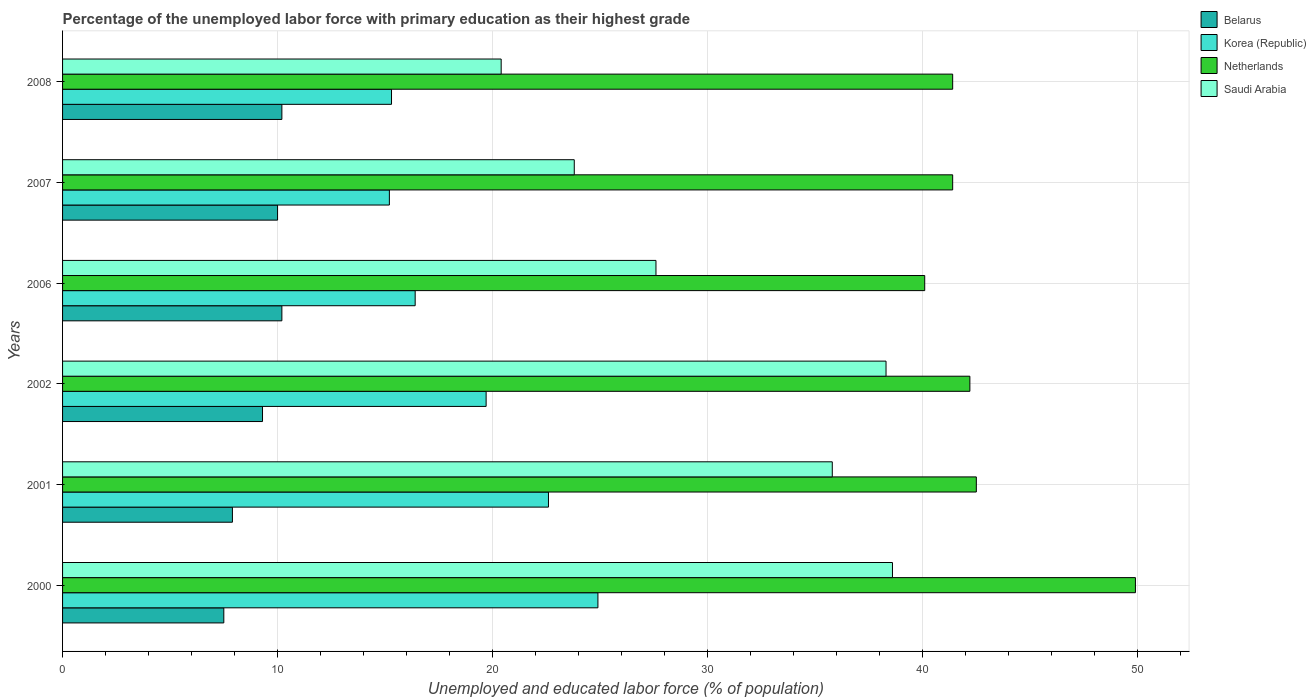How many groups of bars are there?
Keep it short and to the point. 6. How many bars are there on the 1st tick from the top?
Provide a succinct answer. 4. How many bars are there on the 3rd tick from the bottom?
Provide a short and direct response. 4. What is the label of the 3rd group of bars from the top?
Offer a very short reply. 2006. What is the percentage of the unemployed labor force with primary education in Netherlands in 2007?
Provide a short and direct response. 41.4. Across all years, what is the maximum percentage of the unemployed labor force with primary education in Saudi Arabia?
Keep it short and to the point. 38.6. What is the total percentage of the unemployed labor force with primary education in Netherlands in the graph?
Provide a short and direct response. 257.5. What is the difference between the percentage of the unemployed labor force with primary education in Korea (Republic) in 2006 and that in 2007?
Offer a terse response. 1.2. What is the difference between the percentage of the unemployed labor force with primary education in Korea (Republic) in 2007 and the percentage of the unemployed labor force with primary education in Saudi Arabia in 2001?
Your response must be concise. -20.6. What is the average percentage of the unemployed labor force with primary education in Belarus per year?
Your answer should be very brief. 9.18. In the year 2006, what is the difference between the percentage of the unemployed labor force with primary education in Netherlands and percentage of the unemployed labor force with primary education in Saudi Arabia?
Provide a succinct answer. 12.5. In how many years, is the percentage of the unemployed labor force with primary education in Belarus greater than 10 %?
Offer a terse response. 2. What is the ratio of the percentage of the unemployed labor force with primary education in Netherlands in 2000 to that in 2007?
Provide a succinct answer. 1.21. Is the percentage of the unemployed labor force with primary education in Netherlands in 2006 less than that in 2008?
Offer a very short reply. Yes. Is the difference between the percentage of the unemployed labor force with primary education in Netherlands in 2001 and 2006 greater than the difference between the percentage of the unemployed labor force with primary education in Saudi Arabia in 2001 and 2006?
Give a very brief answer. No. What is the difference between the highest and the second highest percentage of the unemployed labor force with primary education in Saudi Arabia?
Provide a succinct answer. 0.3. What is the difference between the highest and the lowest percentage of the unemployed labor force with primary education in Saudi Arabia?
Give a very brief answer. 18.2. In how many years, is the percentage of the unemployed labor force with primary education in Belarus greater than the average percentage of the unemployed labor force with primary education in Belarus taken over all years?
Your answer should be very brief. 4. Is the sum of the percentage of the unemployed labor force with primary education in Netherlands in 2002 and 2008 greater than the maximum percentage of the unemployed labor force with primary education in Korea (Republic) across all years?
Ensure brevity in your answer.  Yes. Is it the case that in every year, the sum of the percentage of the unemployed labor force with primary education in Belarus and percentage of the unemployed labor force with primary education in Netherlands is greater than the sum of percentage of the unemployed labor force with primary education in Saudi Arabia and percentage of the unemployed labor force with primary education in Korea (Republic)?
Offer a terse response. No. What does the 3rd bar from the bottom in 2000 represents?
Provide a succinct answer. Netherlands. Is it the case that in every year, the sum of the percentage of the unemployed labor force with primary education in Saudi Arabia and percentage of the unemployed labor force with primary education in Netherlands is greater than the percentage of the unemployed labor force with primary education in Belarus?
Make the answer very short. Yes. Does the graph contain grids?
Keep it short and to the point. Yes. How many legend labels are there?
Keep it short and to the point. 4. How are the legend labels stacked?
Provide a succinct answer. Vertical. What is the title of the graph?
Offer a very short reply. Percentage of the unemployed labor force with primary education as their highest grade. Does "Cambodia" appear as one of the legend labels in the graph?
Your answer should be compact. No. What is the label or title of the X-axis?
Your response must be concise. Unemployed and educated labor force (% of population). What is the Unemployed and educated labor force (% of population) of Korea (Republic) in 2000?
Your response must be concise. 24.9. What is the Unemployed and educated labor force (% of population) in Netherlands in 2000?
Your answer should be compact. 49.9. What is the Unemployed and educated labor force (% of population) in Saudi Arabia in 2000?
Offer a terse response. 38.6. What is the Unemployed and educated labor force (% of population) in Belarus in 2001?
Keep it short and to the point. 7.9. What is the Unemployed and educated labor force (% of population) in Korea (Republic) in 2001?
Your answer should be very brief. 22.6. What is the Unemployed and educated labor force (% of population) of Netherlands in 2001?
Your answer should be very brief. 42.5. What is the Unemployed and educated labor force (% of population) of Saudi Arabia in 2001?
Provide a short and direct response. 35.8. What is the Unemployed and educated labor force (% of population) of Belarus in 2002?
Make the answer very short. 9.3. What is the Unemployed and educated labor force (% of population) in Korea (Republic) in 2002?
Your answer should be compact. 19.7. What is the Unemployed and educated labor force (% of population) in Netherlands in 2002?
Your response must be concise. 42.2. What is the Unemployed and educated labor force (% of population) in Saudi Arabia in 2002?
Your answer should be compact. 38.3. What is the Unemployed and educated labor force (% of population) of Belarus in 2006?
Provide a succinct answer. 10.2. What is the Unemployed and educated labor force (% of population) of Korea (Republic) in 2006?
Offer a terse response. 16.4. What is the Unemployed and educated labor force (% of population) of Netherlands in 2006?
Your answer should be compact. 40.1. What is the Unemployed and educated labor force (% of population) of Saudi Arabia in 2006?
Your answer should be compact. 27.6. What is the Unemployed and educated labor force (% of population) in Korea (Republic) in 2007?
Your response must be concise. 15.2. What is the Unemployed and educated labor force (% of population) in Netherlands in 2007?
Make the answer very short. 41.4. What is the Unemployed and educated labor force (% of population) of Saudi Arabia in 2007?
Your answer should be compact. 23.8. What is the Unemployed and educated labor force (% of population) of Belarus in 2008?
Ensure brevity in your answer.  10.2. What is the Unemployed and educated labor force (% of population) of Korea (Republic) in 2008?
Offer a very short reply. 15.3. What is the Unemployed and educated labor force (% of population) of Netherlands in 2008?
Provide a succinct answer. 41.4. What is the Unemployed and educated labor force (% of population) of Saudi Arabia in 2008?
Provide a succinct answer. 20.4. Across all years, what is the maximum Unemployed and educated labor force (% of population) in Belarus?
Provide a short and direct response. 10.2. Across all years, what is the maximum Unemployed and educated labor force (% of population) of Korea (Republic)?
Provide a short and direct response. 24.9. Across all years, what is the maximum Unemployed and educated labor force (% of population) of Netherlands?
Your answer should be compact. 49.9. Across all years, what is the maximum Unemployed and educated labor force (% of population) of Saudi Arabia?
Give a very brief answer. 38.6. Across all years, what is the minimum Unemployed and educated labor force (% of population) in Belarus?
Your answer should be compact. 7.5. Across all years, what is the minimum Unemployed and educated labor force (% of population) in Korea (Republic)?
Give a very brief answer. 15.2. Across all years, what is the minimum Unemployed and educated labor force (% of population) of Netherlands?
Offer a very short reply. 40.1. Across all years, what is the minimum Unemployed and educated labor force (% of population) in Saudi Arabia?
Make the answer very short. 20.4. What is the total Unemployed and educated labor force (% of population) of Belarus in the graph?
Your answer should be very brief. 55.1. What is the total Unemployed and educated labor force (% of population) in Korea (Republic) in the graph?
Provide a succinct answer. 114.1. What is the total Unemployed and educated labor force (% of population) of Netherlands in the graph?
Provide a short and direct response. 257.5. What is the total Unemployed and educated labor force (% of population) in Saudi Arabia in the graph?
Offer a very short reply. 184.5. What is the difference between the Unemployed and educated labor force (% of population) of Belarus in 2000 and that in 2001?
Your response must be concise. -0.4. What is the difference between the Unemployed and educated labor force (% of population) in Korea (Republic) in 2000 and that in 2001?
Your answer should be compact. 2.3. What is the difference between the Unemployed and educated labor force (% of population) in Belarus in 2000 and that in 2002?
Your response must be concise. -1.8. What is the difference between the Unemployed and educated labor force (% of population) in Korea (Republic) in 2000 and that in 2002?
Offer a terse response. 5.2. What is the difference between the Unemployed and educated labor force (% of population) in Netherlands in 2000 and that in 2002?
Give a very brief answer. 7.7. What is the difference between the Unemployed and educated labor force (% of population) in Belarus in 2000 and that in 2006?
Give a very brief answer. -2.7. What is the difference between the Unemployed and educated labor force (% of population) in Korea (Republic) in 2000 and that in 2006?
Your answer should be very brief. 8.5. What is the difference between the Unemployed and educated labor force (% of population) in Korea (Republic) in 2000 and that in 2008?
Your answer should be very brief. 9.6. What is the difference between the Unemployed and educated labor force (% of population) in Netherlands in 2000 and that in 2008?
Offer a terse response. 8.5. What is the difference between the Unemployed and educated labor force (% of population) in Saudi Arabia in 2000 and that in 2008?
Provide a short and direct response. 18.2. What is the difference between the Unemployed and educated labor force (% of population) in Belarus in 2001 and that in 2006?
Make the answer very short. -2.3. What is the difference between the Unemployed and educated labor force (% of population) of Netherlands in 2001 and that in 2006?
Your answer should be compact. 2.4. What is the difference between the Unemployed and educated labor force (% of population) of Saudi Arabia in 2001 and that in 2006?
Your response must be concise. 8.2. What is the difference between the Unemployed and educated labor force (% of population) of Netherlands in 2001 and that in 2007?
Offer a terse response. 1.1. What is the difference between the Unemployed and educated labor force (% of population) in Saudi Arabia in 2001 and that in 2007?
Provide a short and direct response. 12. What is the difference between the Unemployed and educated labor force (% of population) in Saudi Arabia in 2001 and that in 2008?
Give a very brief answer. 15.4. What is the difference between the Unemployed and educated labor force (% of population) of Belarus in 2002 and that in 2007?
Ensure brevity in your answer.  -0.7. What is the difference between the Unemployed and educated labor force (% of population) in Korea (Republic) in 2002 and that in 2007?
Provide a succinct answer. 4.5. What is the difference between the Unemployed and educated labor force (% of population) in Netherlands in 2002 and that in 2007?
Provide a short and direct response. 0.8. What is the difference between the Unemployed and educated labor force (% of population) in Netherlands in 2002 and that in 2008?
Offer a very short reply. 0.8. What is the difference between the Unemployed and educated labor force (% of population) in Korea (Republic) in 2006 and that in 2007?
Your answer should be compact. 1.2. What is the difference between the Unemployed and educated labor force (% of population) of Saudi Arabia in 2006 and that in 2007?
Offer a terse response. 3.8. What is the difference between the Unemployed and educated labor force (% of population) of Saudi Arabia in 2006 and that in 2008?
Give a very brief answer. 7.2. What is the difference between the Unemployed and educated labor force (% of population) in Saudi Arabia in 2007 and that in 2008?
Make the answer very short. 3.4. What is the difference between the Unemployed and educated labor force (% of population) in Belarus in 2000 and the Unemployed and educated labor force (% of population) in Korea (Republic) in 2001?
Provide a succinct answer. -15.1. What is the difference between the Unemployed and educated labor force (% of population) in Belarus in 2000 and the Unemployed and educated labor force (% of population) in Netherlands in 2001?
Make the answer very short. -35. What is the difference between the Unemployed and educated labor force (% of population) of Belarus in 2000 and the Unemployed and educated labor force (% of population) of Saudi Arabia in 2001?
Ensure brevity in your answer.  -28.3. What is the difference between the Unemployed and educated labor force (% of population) of Korea (Republic) in 2000 and the Unemployed and educated labor force (% of population) of Netherlands in 2001?
Make the answer very short. -17.6. What is the difference between the Unemployed and educated labor force (% of population) in Korea (Republic) in 2000 and the Unemployed and educated labor force (% of population) in Saudi Arabia in 2001?
Give a very brief answer. -10.9. What is the difference between the Unemployed and educated labor force (% of population) of Netherlands in 2000 and the Unemployed and educated labor force (% of population) of Saudi Arabia in 2001?
Offer a very short reply. 14.1. What is the difference between the Unemployed and educated labor force (% of population) of Belarus in 2000 and the Unemployed and educated labor force (% of population) of Korea (Republic) in 2002?
Your answer should be very brief. -12.2. What is the difference between the Unemployed and educated labor force (% of population) in Belarus in 2000 and the Unemployed and educated labor force (% of population) in Netherlands in 2002?
Provide a short and direct response. -34.7. What is the difference between the Unemployed and educated labor force (% of population) of Belarus in 2000 and the Unemployed and educated labor force (% of population) of Saudi Arabia in 2002?
Provide a short and direct response. -30.8. What is the difference between the Unemployed and educated labor force (% of population) of Korea (Republic) in 2000 and the Unemployed and educated labor force (% of population) of Netherlands in 2002?
Your answer should be compact. -17.3. What is the difference between the Unemployed and educated labor force (% of population) in Korea (Republic) in 2000 and the Unemployed and educated labor force (% of population) in Saudi Arabia in 2002?
Ensure brevity in your answer.  -13.4. What is the difference between the Unemployed and educated labor force (% of population) of Belarus in 2000 and the Unemployed and educated labor force (% of population) of Netherlands in 2006?
Offer a terse response. -32.6. What is the difference between the Unemployed and educated labor force (% of population) in Belarus in 2000 and the Unemployed and educated labor force (% of population) in Saudi Arabia in 2006?
Your answer should be very brief. -20.1. What is the difference between the Unemployed and educated labor force (% of population) of Korea (Republic) in 2000 and the Unemployed and educated labor force (% of population) of Netherlands in 2006?
Your response must be concise. -15.2. What is the difference between the Unemployed and educated labor force (% of population) of Korea (Republic) in 2000 and the Unemployed and educated labor force (% of population) of Saudi Arabia in 2006?
Provide a short and direct response. -2.7. What is the difference between the Unemployed and educated labor force (% of population) of Netherlands in 2000 and the Unemployed and educated labor force (% of population) of Saudi Arabia in 2006?
Offer a terse response. 22.3. What is the difference between the Unemployed and educated labor force (% of population) in Belarus in 2000 and the Unemployed and educated labor force (% of population) in Netherlands in 2007?
Keep it short and to the point. -33.9. What is the difference between the Unemployed and educated labor force (% of population) in Belarus in 2000 and the Unemployed and educated labor force (% of population) in Saudi Arabia in 2007?
Give a very brief answer. -16.3. What is the difference between the Unemployed and educated labor force (% of population) of Korea (Republic) in 2000 and the Unemployed and educated labor force (% of population) of Netherlands in 2007?
Your answer should be compact. -16.5. What is the difference between the Unemployed and educated labor force (% of population) of Korea (Republic) in 2000 and the Unemployed and educated labor force (% of population) of Saudi Arabia in 2007?
Keep it short and to the point. 1.1. What is the difference between the Unemployed and educated labor force (% of population) of Netherlands in 2000 and the Unemployed and educated labor force (% of population) of Saudi Arabia in 2007?
Offer a very short reply. 26.1. What is the difference between the Unemployed and educated labor force (% of population) of Belarus in 2000 and the Unemployed and educated labor force (% of population) of Netherlands in 2008?
Provide a short and direct response. -33.9. What is the difference between the Unemployed and educated labor force (% of population) of Korea (Republic) in 2000 and the Unemployed and educated labor force (% of population) of Netherlands in 2008?
Ensure brevity in your answer.  -16.5. What is the difference between the Unemployed and educated labor force (% of population) of Netherlands in 2000 and the Unemployed and educated labor force (% of population) of Saudi Arabia in 2008?
Your answer should be very brief. 29.5. What is the difference between the Unemployed and educated labor force (% of population) of Belarus in 2001 and the Unemployed and educated labor force (% of population) of Netherlands in 2002?
Keep it short and to the point. -34.3. What is the difference between the Unemployed and educated labor force (% of population) in Belarus in 2001 and the Unemployed and educated labor force (% of population) in Saudi Arabia in 2002?
Your response must be concise. -30.4. What is the difference between the Unemployed and educated labor force (% of population) of Korea (Republic) in 2001 and the Unemployed and educated labor force (% of population) of Netherlands in 2002?
Offer a terse response. -19.6. What is the difference between the Unemployed and educated labor force (% of population) of Korea (Republic) in 2001 and the Unemployed and educated labor force (% of population) of Saudi Arabia in 2002?
Provide a succinct answer. -15.7. What is the difference between the Unemployed and educated labor force (% of population) of Netherlands in 2001 and the Unemployed and educated labor force (% of population) of Saudi Arabia in 2002?
Keep it short and to the point. 4.2. What is the difference between the Unemployed and educated labor force (% of population) in Belarus in 2001 and the Unemployed and educated labor force (% of population) in Korea (Republic) in 2006?
Your response must be concise. -8.5. What is the difference between the Unemployed and educated labor force (% of population) of Belarus in 2001 and the Unemployed and educated labor force (% of population) of Netherlands in 2006?
Your response must be concise. -32.2. What is the difference between the Unemployed and educated labor force (% of population) of Belarus in 2001 and the Unemployed and educated labor force (% of population) of Saudi Arabia in 2006?
Offer a very short reply. -19.7. What is the difference between the Unemployed and educated labor force (% of population) of Korea (Republic) in 2001 and the Unemployed and educated labor force (% of population) of Netherlands in 2006?
Your answer should be very brief. -17.5. What is the difference between the Unemployed and educated labor force (% of population) of Korea (Republic) in 2001 and the Unemployed and educated labor force (% of population) of Saudi Arabia in 2006?
Keep it short and to the point. -5. What is the difference between the Unemployed and educated labor force (% of population) in Belarus in 2001 and the Unemployed and educated labor force (% of population) in Netherlands in 2007?
Offer a very short reply. -33.5. What is the difference between the Unemployed and educated labor force (% of population) in Belarus in 2001 and the Unemployed and educated labor force (% of population) in Saudi Arabia in 2007?
Offer a terse response. -15.9. What is the difference between the Unemployed and educated labor force (% of population) in Korea (Republic) in 2001 and the Unemployed and educated labor force (% of population) in Netherlands in 2007?
Keep it short and to the point. -18.8. What is the difference between the Unemployed and educated labor force (% of population) in Korea (Republic) in 2001 and the Unemployed and educated labor force (% of population) in Saudi Arabia in 2007?
Your answer should be very brief. -1.2. What is the difference between the Unemployed and educated labor force (% of population) in Netherlands in 2001 and the Unemployed and educated labor force (% of population) in Saudi Arabia in 2007?
Give a very brief answer. 18.7. What is the difference between the Unemployed and educated labor force (% of population) in Belarus in 2001 and the Unemployed and educated labor force (% of population) in Netherlands in 2008?
Your answer should be very brief. -33.5. What is the difference between the Unemployed and educated labor force (% of population) of Korea (Republic) in 2001 and the Unemployed and educated labor force (% of population) of Netherlands in 2008?
Your answer should be very brief. -18.8. What is the difference between the Unemployed and educated labor force (% of population) in Korea (Republic) in 2001 and the Unemployed and educated labor force (% of population) in Saudi Arabia in 2008?
Offer a very short reply. 2.2. What is the difference between the Unemployed and educated labor force (% of population) of Netherlands in 2001 and the Unemployed and educated labor force (% of population) of Saudi Arabia in 2008?
Offer a very short reply. 22.1. What is the difference between the Unemployed and educated labor force (% of population) of Belarus in 2002 and the Unemployed and educated labor force (% of population) of Korea (Republic) in 2006?
Provide a succinct answer. -7.1. What is the difference between the Unemployed and educated labor force (% of population) of Belarus in 2002 and the Unemployed and educated labor force (% of population) of Netherlands in 2006?
Ensure brevity in your answer.  -30.8. What is the difference between the Unemployed and educated labor force (% of population) of Belarus in 2002 and the Unemployed and educated labor force (% of population) of Saudi Arabia in 2006?
Keep it short and to the point. -18.3. What is the difference between the Unemployed and educated labor force (% of population) of Korea (Republic) in 2002 and the Unemployed and educated labor force (% of population) of Netherlands in 2006?
Offer a very short reply. -20.4. What is the difference between the Unemployed and educated labor force (% of population) of Netherlands in 2002 and the Unemployed and educated labor force (% of population) of Saudi Arabia in 2006?
Offer a very short reply. 14.6. What is the difference between the Unemployed and educated labor force (% of population) of Belarus in 2002 and the Unemployed and educated labor force (% of population) of Netherlands in 2007?
Offer a terse response. -32.1. What is the difference between the Unemployed and educated labor force (% of population) of Korea (Republic) in 2002 and the Unemployed and educated labor force (% of population) of Netherlands in 2007?
Keep it short and to the point. -21.7. What is the difference between the Unemployed and educated labor force (% of population) in Netherlands in 2002 and the Unemployed and educated labor force (% of population) in Saudi Arabia in 2007?
Make the answer very short. 18.4. What is the difference between the Unemployed and educated labor force (% of population) of Belarus in 2002 and the Unemployed and educated labor force (% of population) of Netherlands in 2008?
Provide a short and direct response. -32.1. What is the difference between the Unemployed and educated labor force (% of population) of Korea (Republic) in 2002 and the Unemployed and educated labor force (% of population) of Netherlands in 2008?
Ensure brevity in your answer.  -21.7. What is the difference between the Unemployed and educated labor force (% of population) in Netherlands in 2002 and the Unemployed and educated labor force (% of population) in Saudi Arabia in 2008?
Make the answer very short. 21.8. What is the difference between the Unemployed and educated labor force (% of population) of Belarus in 2006 and the Unemployed and educated labor force (% of population) of Netherlands in 2007?
Ensure brevity in your answer.  -31.2. What is the difference between the Unemployed and educated labor force (% of population) of Belarus in 2006 and the Unemployed and educated labor force (% of population) of Saudi Arabia in 2007?
Your answer should be very brief. -13.6. What is the difference between the Unemployed and educated labor force (% of population) of Korea (Republic) in 2006 and the Unemployed and educated labor force (% of population) of Netherlands in 2007?
Offer a terse response. -25. What is the difference between the Unemployed and educated labor force (% of population) in Netherlands in 2006 and the Unemployed and educated labor force (% of population) in Saudi Arabia in 2007?
Your answer should be very brief. 16.3. What is the difference between the Unemployed and educated labor force (% of population) in Belarus in 2006 and the Unemployed and educated labor force (% of population) in Korea (Republic) in 2008?
Your answer should be compact. -5.1. What is the difference between the Unemployed and educated labor force (% of population) in Belarus in 2006 and the Unemployed and educated labor force (% of population) in Netherlands in 2008?
Keep it short and to the point. -31.2. What is the difference between the Unemployed and educated labor force (% of population) in Belarus in 2006 and the Unemployed and educated labor force (% of population) in Saudi Arabia in 2008?
Your answer should be compact. -10.2. What is the difference between the Unemployed and educated labor force (% of population) of Korea (Republic) in 2006 and the Unemployed and educated labor force (% of population) of Netherlands in 2008?
Offer a very short reply. -25. What is the difference between the Unemployed and educated labor force (% of population) in Korea (Republic) in 2006 and the Unemployed and educated labor force (% of population) in Saudi Arabia in 2008?
Give a very brief answer. -4. What is the difference between the Unemployed and educated labor force (% of population) in Netherlands in 2006 and the Unemployed and educated labor force (% of population) in Saudi Arabia in 2008?
Your answer should be compact. 19.7. What is the difference between the Unemployed and educated labor force (% of population) of Belarus in 2007 and the Unemployed and educated labor force (% of population) of Korea (Republic) in 2008?
Your answer should be very brief. -5.3. What is the difference between the Unemployed and educated labor force (% of population) of Belarus in 2007 and the Unemployed and educated labor force (% of population) of Netherlands in 2008?
Give a very brief answer. -31.4. What is the difference between the Unemployed and educated labor force (% of population) of Belarus in 2007 and the Unemployed and educated labor force (% of population) of Saudi Arabia in 2008?
Your answer should be compact. -10.4. What is the difference between the Unemployed and educated labor force (% of population) of Korea (Republic) in 2007 and the Unemployed and educated labor force (% of population) of Netherlands in 2008?
Your answer should be very brief. -26.2. What is the average Unemployed and educated labor force (% of population) of Belarus per year?
Offer a very short reply. 9.18. What is the average Unemployed and educated labor force (% of population) in Korea (Republic) per year?
Make the answer very short. 19.02. What is the average Unemployed and educated labor force (% of population) in Netherlands per year?
Ensure brevity in your answer.  42.92. What is the average Unemployed and educated labor force (% of population) in Saudi Arabia per year?
Provide a succinct answer. 30.75. In the year 2000, what is the difference between the Unemployed and educated labor force (% of population) of Belarus and Unemployed and educated labor force (% of population) of Korea (Republic)?
Your answer should be compact. -17.4. In the year 2000, what is the difference between the Unemployed and educated labor force (% of population) in Belarus and Unemployed and educated labor force (% of population) in Netherlands?
Offer a terse response. -42.4. In the year 2000, what is the difference between the Unemployed and educated labor force (% of population) in Belarus and Unemployed and educated labor force (% of population) in Saudi Arabia?
Your answer should be very brief. -31.1. In the year 2000, what is the difference between the Unemployed and educated labor force (% of population) of Korea (Republic) and Unemployed and educated labor force (% of population) of Saudi Arabia?
Your answer should be very brief. -13.7. In the year 2000, what is the difference between the Unemployed and educated labor force (% of population) in Netherlands and Unemployed and educated labor force (% of population) in Saudi Arabia?
Your response must be concise. 11.3. In the year 2001, what is the difference between the Unemployed and educated labor force (% of population) of Belarus and Unemployed and educated labor force (% of population) of Korea (Republic)?
Your answer should be very brief. -14.7. In the year 2001, what is the difference between the Unemployed and educated labor force (% of population) in Belarus and Unemployed and educated labor force (% of population) in Netherlands?
Provide a succinct answer. -34.6. In the year 2001, what is the difference between the Unemployed and educated labor force (% of population) in Belarus and Unemployed and educated labor force (% of population) in Saudi Arabia?
Keep it short and to the point. -27.9. In the year 2001, what is the difference between the Unemployed and educated labor force (% of population) of Korea (Republic) and Unemployed and educated labor force (% of population) of Netherlands?
Your response must be concise. -19.9. In the year 2001, what is the difference between the Unemployed and educated labor force (% of population) of Netherlands and Unemployed and educated labor force (% of population) of Saudi Arabia?
Offer a very short reply. 6.7. In the year 2002, what is the difference between the Unemployed and educated labor force (% of population) in Belarus and Unemployed and educated labor force (% of population) in Korea (Republic)?
Provide a short and direct response. -10.4. In the year 2002, what is the difference between the Unemployed and educated labor force (% of population) of Belarus and Unemployed and educated labor force (% of population) of Netherlands?
Offer a very short reply. -32.9. In the year 2002, what is the difference between the Unemployed and educated labor force (% of population) of Korea (Republic) and Unemployed and educated labor force (% of population) of Netherlands?
Your answer should be very brief. -22.5. In the year 2002, what is the difference between the Unemployed and educated labor force (% of population) of Korea (Republic) and Unemployed and educated labor force (% of population) of Saudi Arabia?
Ensure brevity in your answer.  -18.6. In the year 2006, what is the difference between the Unemployed and educated labor force (% of population) of Belarus and Unemployed and educated labor force (% of population) of Netherlands?
Provide a short and direct response. -29.9. In the year 2006, what is the difference between the Unemployed and educated labor force (% of population) of Belarus and Unemployed and educated labor force (% of population) of Saudi Arabia?
Offer a terse response. -17.4. In the year 2006, what is the difference between the Unemployed and educated labor force (% of population) in Korea (Republic) and Unemployed and educated labor force (% of population) in Netherlands?
Your answer should be compact. -23.7. In the year 2006, what is the difference between the Unemployed and educated labor force (% of population) of Korea (Republic) and Unemployed and educated labor force (% of population) of Saudi Arabia?
Offer a very short reply. -11.2. In the year 2007, what is the difference between the Unemployed and educated labor force (% of population) in Belarus and Unemployed and educated labor force (% of population) in Korea (Republic)?
Offer a terse response. -5.2. In the year 2007, what is the difference between the Unemployed and educated labor force (% of population) of Belarus and Unemployed and educated labor force (% of population) of Netherlands?
Your answer should be compact. -31.4. In the year 2007, what is the difference between the Unemployed and educated labor force (% of population) of Belarus and Unemployed and educated labor force (% of population) of Saudi Arabia?
Your answer should be compact. -13.8. In the year 2007, what is the difference between the Unemployed and educated labor force (% of population) of Korea (Republic) and Unemployed and educated labor force (% of population) of Netherlands?
Your response must be concise. -26.2. In the year 2008, what is the difference between the Unemployed and educated labor force (% of population) of Belarus and Unemployed and educated labor force (% of population) of Netherlands?
Provide a short and direct response. -31.2. In the year 2008, what is the difference between the Unemployed and educated labor force (% of population) in Belarus and Unemployed and educated labor force (% of population) in Saudi Arabia?
Make the answer very short. -10.2. In the year 2008, what is the difference between the Unemployed and educated labor force (% of population) in Korea (Republic) and Unemployed and educated labor force (% of population) in Netherlands?
Keep it short and to the point. -26.1. In the year 2008, what is the difference between the Unemployed and educated labor force (% of population) in Korea (Republic) and Unemployed and educated labor force (% of population) in Saudi Arabia?
Provide a succinct answer. -5.1. What is the ratio of the Unemployed and educated labor force (% of population) in Belarus in 2000 to that in 2001?
Offer a very short reply. 0.95. What is the ratio of the Unemployed and educated labor force (% of population) in Korea (Republic) in 2000 to that in 2001?
Your answer should be compact. 1.1. What is the ratio of the Unemployed and educated labor force (% of population) of Netherlands in 2000 to that in 2001?
Keep it short and to the point. 1.17. What is the ratio of the Unemployed and educated labor force (% of population) in Saudi Arabia in 2000 to that in 2001?
Give a very brief answer. 1.08. What is the ratio of the Unemployed and educated labor force (% of population) in Belarus in 2000 to that in 2002?
Make the answer very short. 0.81. What is the ratio of the Unemployed and educated labor force (% of population) of Korea (Republic) in 2000 to that in 2002?
Make the answer very short. 1.26. What is the ratio of the Unemployed and educated labor force (% of population) in Netherlands in 2000 to that in 2002?
Offer a very short reply. 1.18. What is the ratio of the Unemployed and educated labor force (% of population) of Belarus in 2000 to that in 2006?
Make the answer very short. 0.74. What is the ratio of the Unemployed and educated labor force (% of population) in Korea (Republic) in 2000 to that in 2006?
Ensure brevity in your answer.  1.52. What is the ratio of the Unemployed and educated labor force (% of population) of Netherlands in 2000 to that in 2006?
Offer a terse response. 1.24. What is the ratio of the Unemployed and educated labor force (% of population) in Saudi Arabia in 2000 to that in 2006?
Your answer should be very brief. 1.4. What is the ratio of the Unemployed and educated labor force (% of population) of Belarus in 2000 to that in 2007?
Give a very brief answer. 0.75. What is the ratio of the Unemployed and educated labor force (% of population) of Korea (Republic) in 2000 to that in 2007?
Offer a very short reply. 1.64. What is the ratio of the Unemployed and educated labor force (% of population) in Netherlands in 2000 to that in 2007?
Your response must be concise. 1.21. What is the ratio of the Unemployed and educated labor force (% of population) of Saudi Arabia in 2000 to that in 2007?
Keep it short and to the point. 1.62. What is the ratio of the Unemployed and educated labor force (% of population) of Belarus in 2000 to that in 2008?
Provide a succinct answer. 0.74. What is the ratio of the Unemployed and educated labor force (% of population) of Korea (Republic) in 2000 to that in 2008?
Make the answer very short. 1.63. What is the ratio of the Unemployed and educated labor force (% of population) of Netherlands in 2000 to that in 2008?
Ensure brevity in your answer.  1.21. What is the ratio of the Unemployed and educated labor force (% of population) in Saudi Arabia in 2000 to that in 2008?
Ensure brevity in your answer.  1.89. What is the ratio of the Unemployed and educated labor force (% of population) in Belarus in 2001 to that in 2002?
Provide a succinct answer. 0.85. What is the ratio of the Unemployed and educated labor force (% of population) of Korea (Republic) in 2001 to that in 2002?
Make the answer very short. 1.15. What is the ratio of the Unemployed and educated labor force (% of population) in Netherlands in 2001 to that in 2002?
Make the answer very short. 1.01. What is the ratio of the Unemployed and educated labor force (% of population) of Saudi Arabia in 2001 to that in 2002?
Make the answer very short. 0.93. What is the ratio of the Unemployed and educated labor force (% of population) of Belarus in 2001 to that in 2006?
Ensure brevity in your answer.  0.77. What is the ratio of the Unemployed and educated labor force (% of population) of Korea (Republic) in 2001 to that in 2006?
Provide a short and direct response. 1.38. What is the ratio of the Unemployed and educated labor force (% of population) of Netherlands in 2001 to that in 2006?
Offer a terse response. 1.06. What is the ratio of the Unemployed and educated labor force (% of population) of Saudi Arabia in 2001 to that in 2006?
Ensure brevity in your answer.  1.3. What is the ratio of the Unemployed and educated labor force (% of population) in Belarus in 2001 to that in 2007?
Offer a very short reply. 0.79. What is the ratio of the Unemployed and educated labor force (% of population) of Korea (Republic) in 2001 to that in 2007?
Your answer should be compact. 1.49. What is the ratio of the Unemployed and educated labor force (% of population) in Netherlands in 2001 to that in 2007?
Offer a terse response. 1.03. What is the ratio of the Unemployed and educated labor force (% of population) of Saudi Arabia in 2001 to that in 2007?
Make the answer very short. 1.5. What is the ratio of the Unemployed and educated labor force (% of population) in Belarus in 2001 to that in 2008?
Ensure brevity in your answer.  0.77. What is the ratio of the Unemployed and educated labor force (% of population) of Korea (Republic) in 2001 to that in 2008?
Your answer should be very brief. 1.48. What is the ratio of the Unemployed and educated labor force (% of population) in Netherlands in 2001 to that in 2008?
Keep it short and to the point. 1.03. What is the ratio of the Unemployed and educated labor force (% of population) of Saudi Arabia in 2001 to that in 2008?
Provide a succinct answer. 1.75. What is the ratio of the Unemployed and educated labor force (% of population) in Belarus in 2002 to that in 2006?
Provide a succinct answer. 0.91. What is the ratio of the Unemployed and educated labor force (% of population) in Korea (Republic) in 2002 to that in 2006?
Make the answer very short. 1.2. What is the ratio of the Unemployed and educated labor force (% of population) of Netherlands in 2002 to that in 2006?
Your answer should be very brief. 1.05. What is the ratio of the Unemployed and educated labor force (% of population) of Saudi Arabia in 2002 to that in 2006?
Provide a succinct answer. 1.39. What is the ratio of the Unemployed and educated labor force (% of population) in Korea (Republic) in 2002 to that in 2007?
Ensure brevity in your answer.  1.3. What is the ratio of the Unemployed and educated labor force (% of population) of Netherlands in 2002 to that in 2007?
Offer a very short reply. 1.02. What is the ratio of the Unemployed and educated labor force (% of population) of Saudi Arabia in 2002 to that in 2007?
Provide a short and direct response. 1.61. What is the ratio of the Unemployed and educated labor force (% of population) of Belarus in 2002 to that in 2008?
Give a very brief answer. 0.91. What is the ratio of the Unemployed and educated labor force (% of population) of Korea (Republic) in 2002 to that in 2008?
Your answer should be very brief. 1.29. What is the ratio of the Unemployed and educated labor force (% of population) in Netherlands in 2002 to that in 2008?
Keep it short and to the point. 1.02. What is the ratio of the Unemployed and educated labor force (% of population) of Saudi Arabia in 2002 to that in 2008?
Your response must be concise. 1.88. What is the ratio of the Unemployed and educated labor force (% of population) of Belarus in 2006 to that in 2007?
Make the answer very short. 1.02. What is the ratio of the Unemployed and educated labor force (% of population) of Korea (Republic) in 2006 to that in 2007?
Your response must be concise. 1.08. What is the ratio of the Unemployed and educated labor force (% of population) in Netherlands in 2006 to that in 2007?
Make the answer very short. 0.97. What is the ratio of the Unemployed and educated labor force (% of population) in Saudi Arabia in 2006 to that in 2007?
Provide a succinct answer. 1.16. What is the ratio of the Unemployed and educated labor force (% of population) of Korea (Republic) in 2006 to that in 2008?
Your answer should be compact. 1.07. What is the ratio of the Unemployed and educated labor force (% of population) of Netherlands in 2006 to that in 2008?
Provide a short and direct response. 0.97. What is the ratio of the Unemployed and educated labor force (% of population) in Saudi Arabia in 2006 to that in 2008?
Make the answer very short. 1.35. What is the ratio of the Unemployed and educated labor force (% of population) of Belarus in 2007 to that in 2008?
Offer a very short reply. 0.98. What is the ratio of the Unemployed and educated labor force (% of population) of Korea (Republic) in 2007 to that in 2008?
Your response must be concise. 0.99. What is the ratio of the Unemployed and educated labor force (% of population) in Netherlands in 2007 to that in 2008?
Offer a very short reply. 1. What is the difference between the highest and the second highest Unemployed and educated labor force (% of population) of Belarus?
Offer a very short reply. 0. What is the difference between the highest and the second highest Unemployed and educated labor force (% of population) of Korea (Republic)?
Offer a terse response. 2.3. What is the difference between the highest and the second highest Unemployed and educated labor force (% of population) of Netherlands?
Your response must be concise. 7.4. What is the difference between the highest and the second highest Unemployed and educated labor force (% of population) in Saudi Arabia?
Provide a succinct answer. 0.3. What is the difference between the highest and the lowest Unemployed and educated labor force (% of population) in Belarus?
Provide a short and direct response. 2.7. What is the difference between the highest and the lowest Unemployed and educated labor force (% of population) in Korea (Republic)?
Provide a short and direct response. 9.7. 